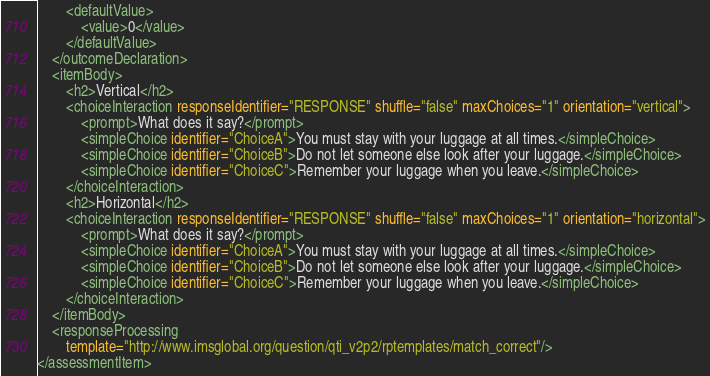Convert code to text. <code><loc_0><loc_0><loc_500><loc_500><_XML_>		<defaultValue>
			<value>0</value>
		</defaultValue>
	</outcomeDeclaration>
	<itemBody>
		<h2>Vertical</h2>
		<choiceInteraction responseIdentifier="RESPONSE" shuffle="false" maxChoices="1" orientation="vertical">
			<prompt>What does it say?</prompt>
			<simpleChoice identifier="ChoiceA">You must stay with your luggage at all times.</simpleChoice>
			<simpleChoice identifier="ChoiceB">Do not let someone else look after your luggage.</simpleChoice>
			<simpleChoice identifier="ChoiceC">Remember your luggage when you leave.</simpleChoice>
		</choiceInteraction>
		<h2>Horizontal</h2>
		<choiceInteraction responseIdentifier="RESPONSE" shuffle="false" maxChoices="1" orientation="horizontal">
			<prompt>What does it say?</prompt>
			<simpleChoice identifier="ChoiceA">You must stay with your luggage at all times.</simpleChoice>
			<simpleChoice identifier="ChoiceB">Do not let someone else look after your luggage.</simpleChoice>
			<simpleChoice identifier="ChoiceC">Remember your luggage when you leave.</simpleChoice>
		</choiceInteraction>
	</itemBody>
	<responseProcessing
		template="http://www.imsglobal.org/question/qti_v2p2/rptemplates/match_correct"/>
</assessmentItem>
</code> 